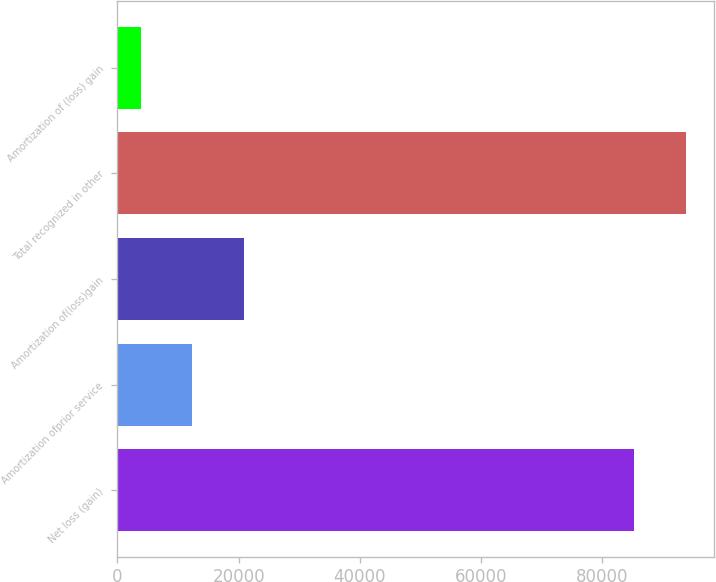Convert chart to OTSL. <chart><loc_0><loc_0><loc_500><loc_500><bar_chart><fcel>Net loss (gain)<fcel>Amortization ofprior service<fcel>Amortization of(loss)gain<fcel>Total recognized in other<fcel>Amortization of (loss) gain<nl><fcel>85265<fcel>12386.9<fcel>20831.8<fcel>93709.9<fcel>3942<nl></chart> 